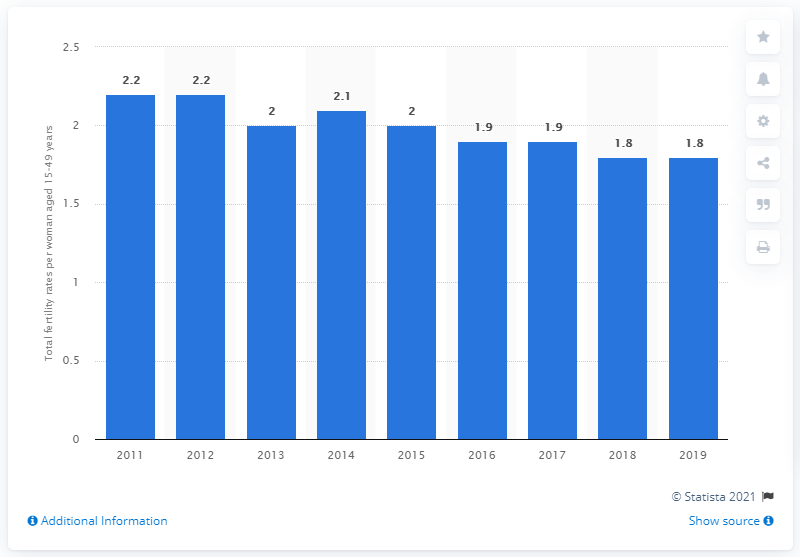Identify some key points in this picture. The total fertility rate in Malaysia in 2019 was 1.8. 